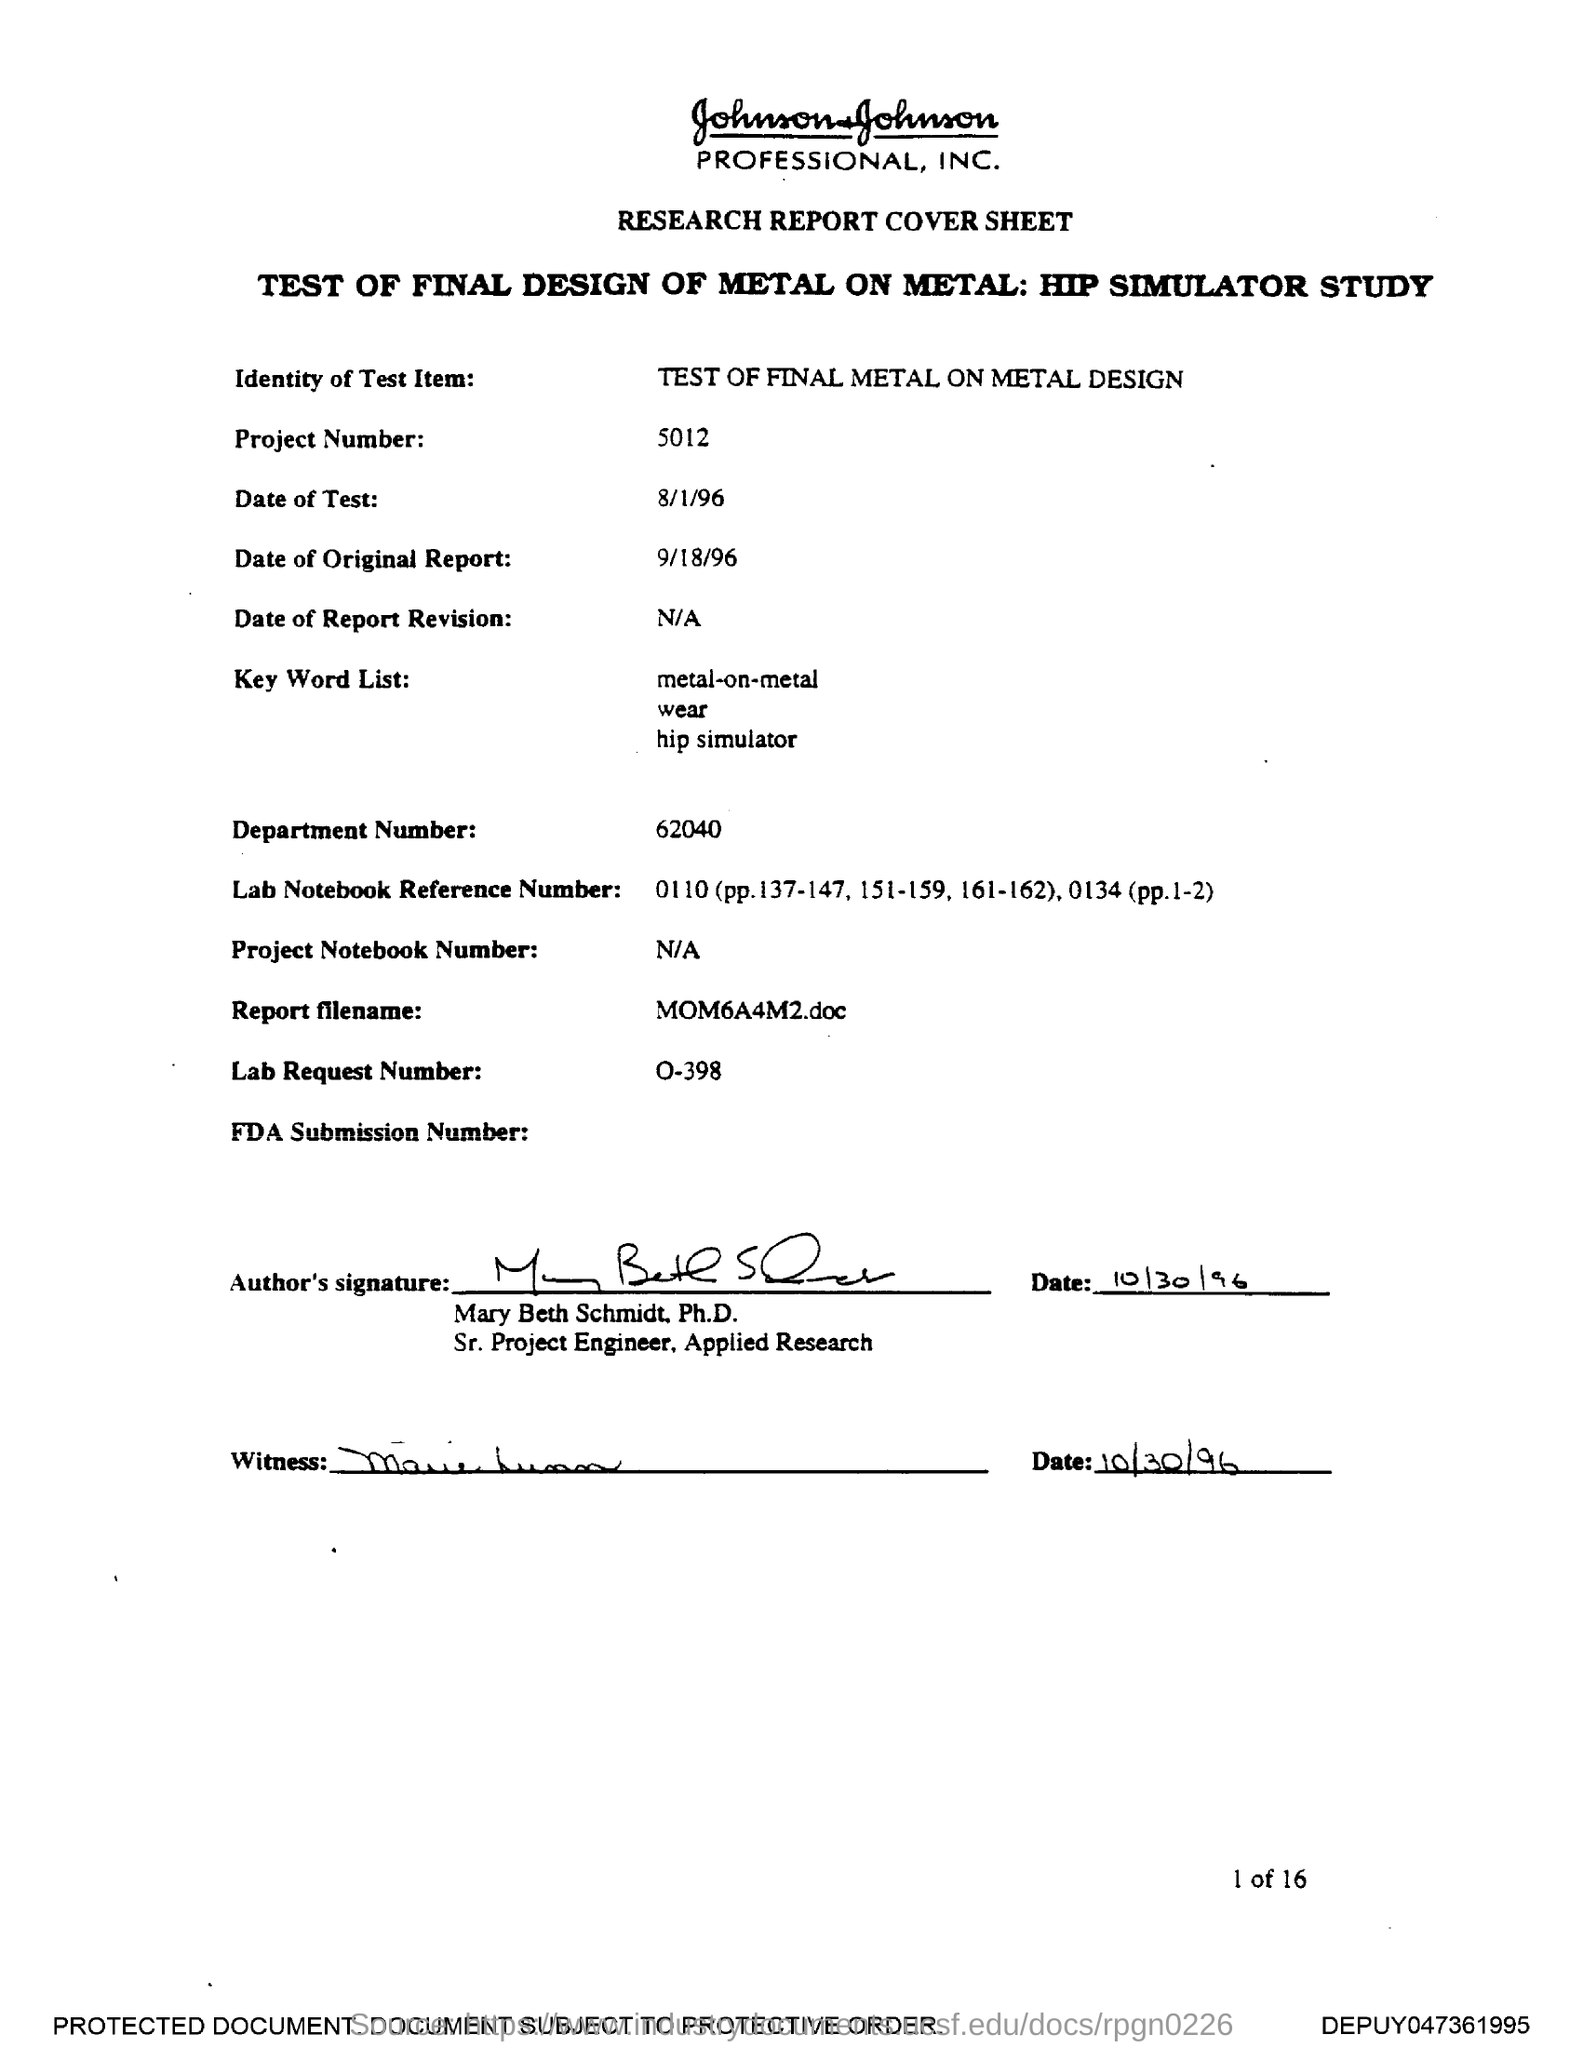Specify some key components in this picture. The report is named "MOM6A4M2.doc". The department number is 62040. The Lab Request Number is o-398. The project number is 5012. 